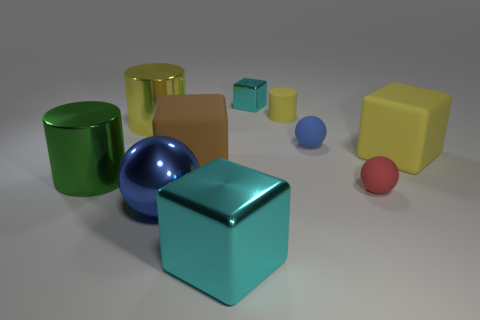What time of day does the lighting in this image suggest? The lighting in this image appears to be diffuse and soft, commonly associated with an overcast day or artificial light sources that do not cast strong shadows. It is not indicative of any particular time of day, given the controlled lighting conditions typical of studio settings. 